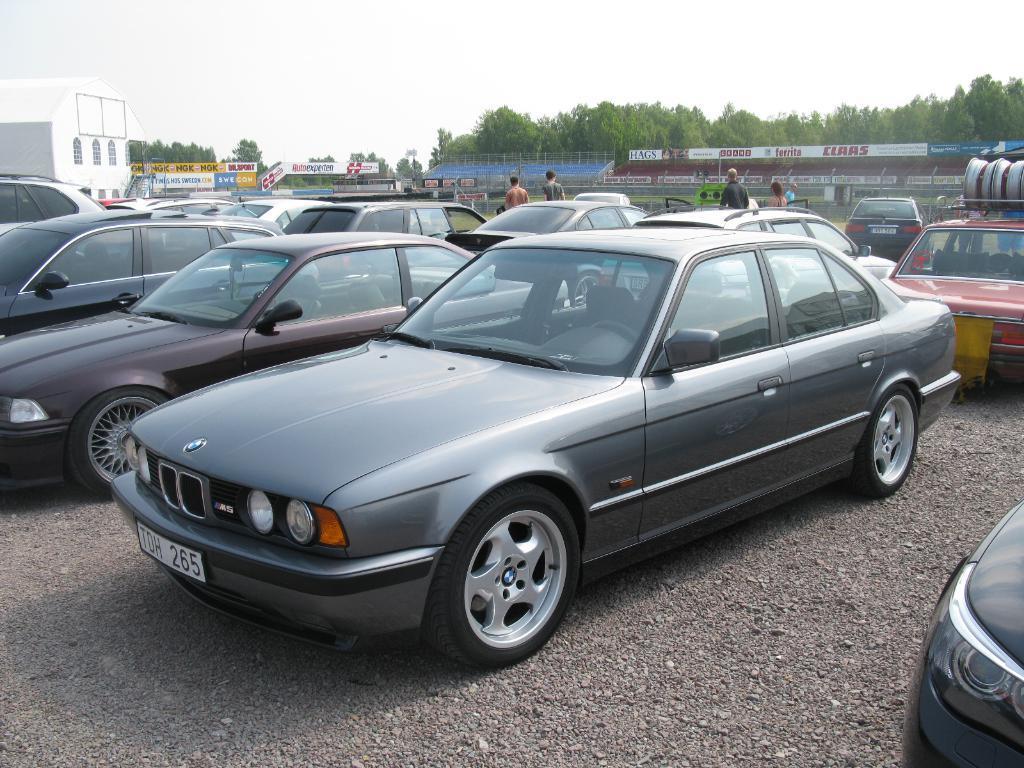Could you give a brief overview of what you see in this image? In the image there are many cars. Behind the cars on the left side there is a building with windows and walls. And also there are many posters. In the background there are trees. And at the top of the image there is a sky. 